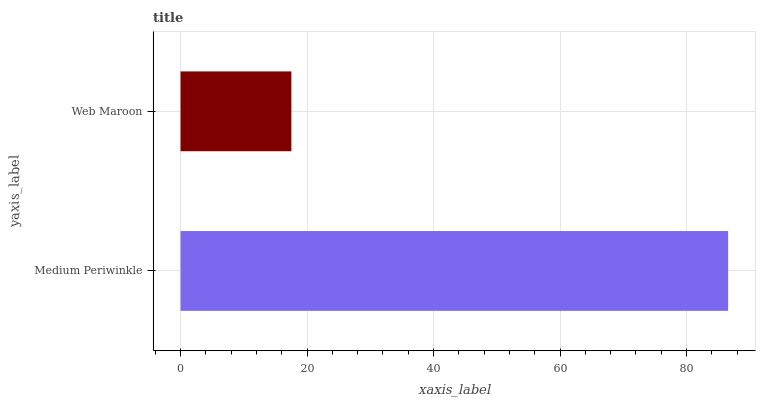Is Web Maroon the minimum?
Answer yes or no. Yes. Is Medium Periwinkle the maximum?
Answer yes or no. Yes. Is Web Maroon the maximum?
Answer yes or no. No. Is Medium Periwinkle greater than Web Maroon?
Answer yes or no. Yes. Is Web Maroon less than Medium Periwinkle?
Answer yes or no. Yes. Is Web Maroon greater than Medium Periwinkle?
Answer yes or no. No. Is Medium Periwinkle less than Web Maroon?
Answer yes or no. No. Is Medium Periwinkle the high median?
Answer yes or no. Yes. Is Web Maroon the low median?
Answer yes or no. Yes. Is Web Maroon the high median?
Answer yes or no. No. Is Medium Periwinkle the low median?
Answer yes or no. No. 